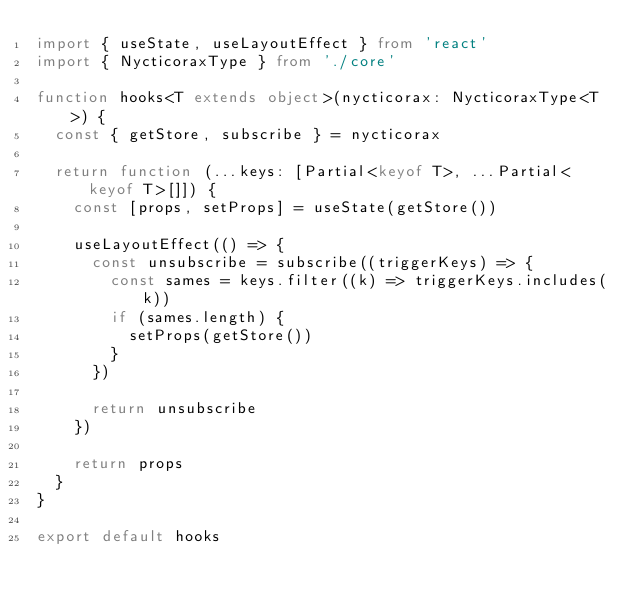Convert code to text. <code><loc_0><loc_0><loc_500><loc_500><_TypeScript_>import { useState, useLayoutEffect } from 'react'
import { NycticoraxType } from './core'

function hooks<T extends object>(nycticorax: NycticoraxType<T>) {
  const { getStore, subscribe } = nycticorax

  return function (...keys: [Partial<keyof T>, ...Partial<keyof T>[]]) {
    const [props, setProps] = useState(getStore())

    useLayoutEffect(() => {
      const unsubscribe = subscribe((triggerKeys) => {
        const sames = keys.filter((k) => triggerKeys.includes(k))
        if (sames.length) {
          setProps(getStore())
        }
      })

      return unsubscribe
    })

    return props
  }
}

export default hooks
</code> 